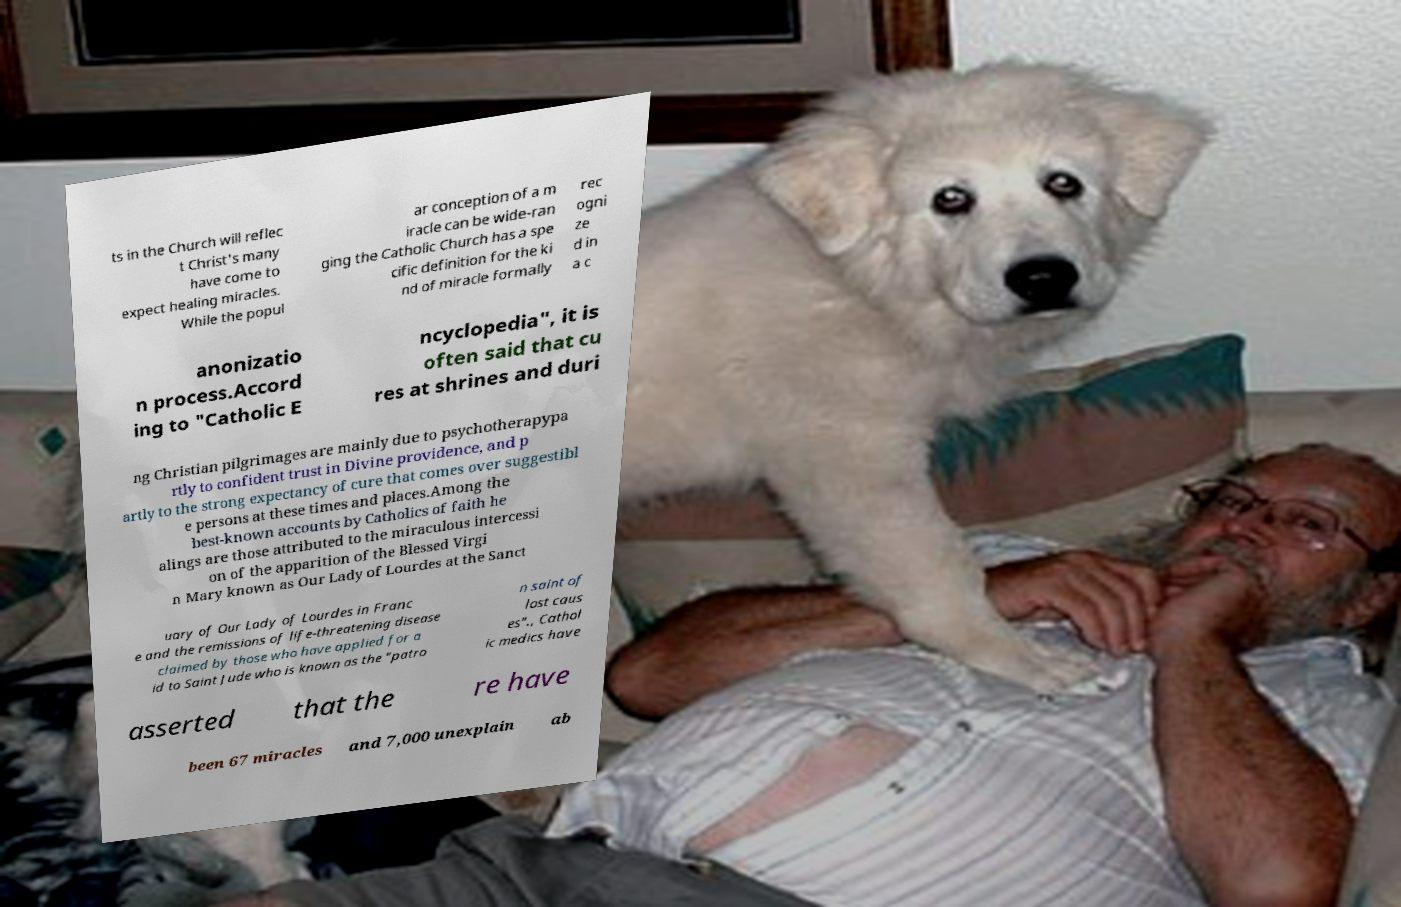I need the written content from this picture converted into text. Can you do that? ts in the Church will reflec t Christ's many have come to expect healing miracles. While the popul ar conception of a m iracle can be wide-ran ging the Catholic Church has a spe cific definition for the ki nd of miracle formally rec ogni ze d in a c anonizatio n process.Accord ing to "Catholic E ncyclopedia", it is often said that cu res at shrines and duri ng Christian pilgrimages are mainly due to psychotherapypa rtly to confident trust in Divine providence, and p artly to the strong expectancy of cure that comes over suggestibl e persons at these times and places.Among the best-known accounts by Catholics of faith he alings are those attributed to the miraculous intercessi on of the apparition of the Blessed Virgi n Mary known as Our Lady of Lourdes at the Sanct uary of Our Lady of Lourdes in Franc e and the remissions of life-threatening disease claimed by those who have applied for a id to Saint Jude who is known as the "patro n saint of lost caus es"., Cathol ic medics have asserted that the re have been 67 miracles and 7,000 unexplain ab 